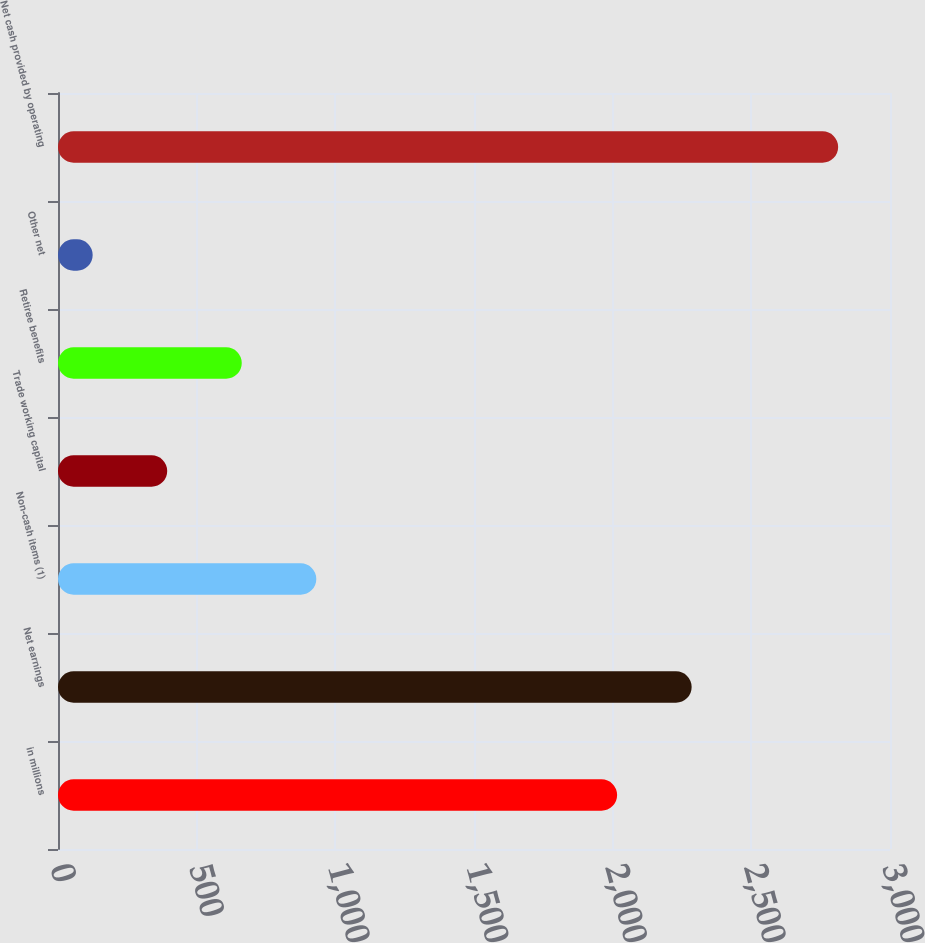Convert chart. <chart><loc_0><loc_0><loc_500><loc_500><bar_chart><fcel>in millions<fcel>Net earnings<fcel>Non-cash items (1)<fcel>Trade working capital<fcel>Retiree benefits<fcel>Other net<fcel>Net cash provided by operating<nl><fcel>2016<fcel>2284.8<fcel>931.4<fcel>393.8<fcel>662.6<fcel>125<fcel>2813<nl></chart> 